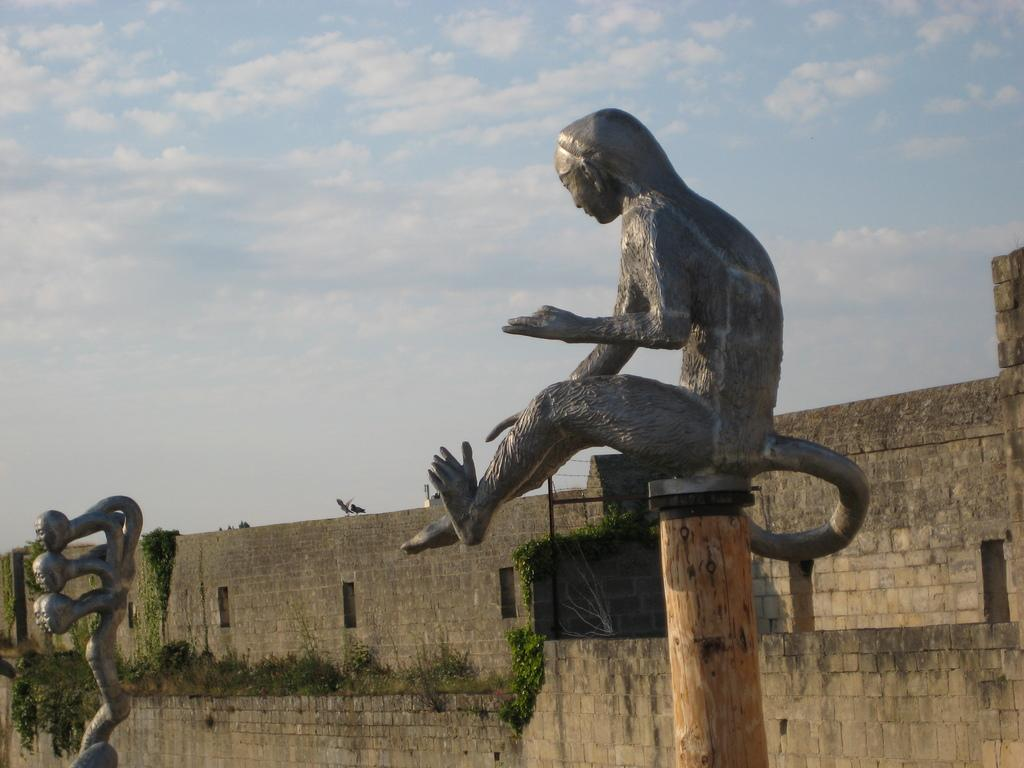How many sculptures can be seen in the image? There are 2 sculptures in the image. What is the background of the sculptures in the image? There is a stone wall in the image. What is growing on the stone wall? Plants are present on the stone wall. What hobbies are the sculptures engaged in during the dinner scene in the image? There is no dinner scene or indication of hobbies in the image; it features 2 sculptures and a stone wall with plants. 